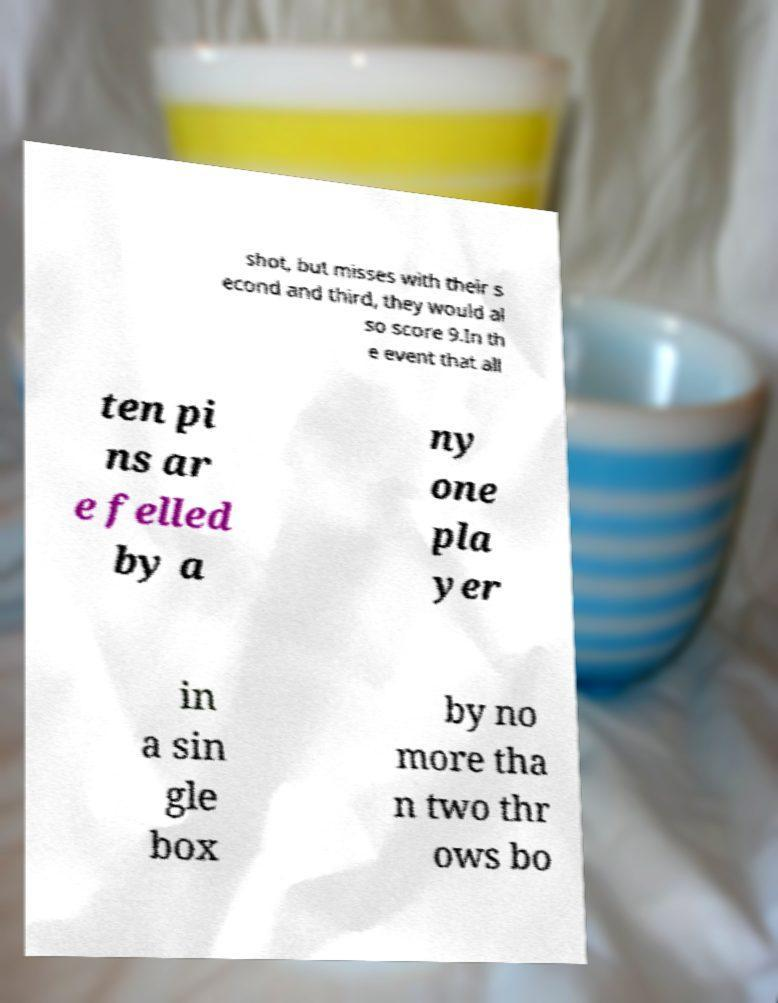Can you read and provide the text displayed in the image?This photo seems to have some interesting text. Can you extract and type it out for me? shot, but misses with their s econd and third, they would al so score 9.In th e event that all ten pi ns ar e felled by a ny one pla yer in a sin gle box by no more tha n two thr ows bo 